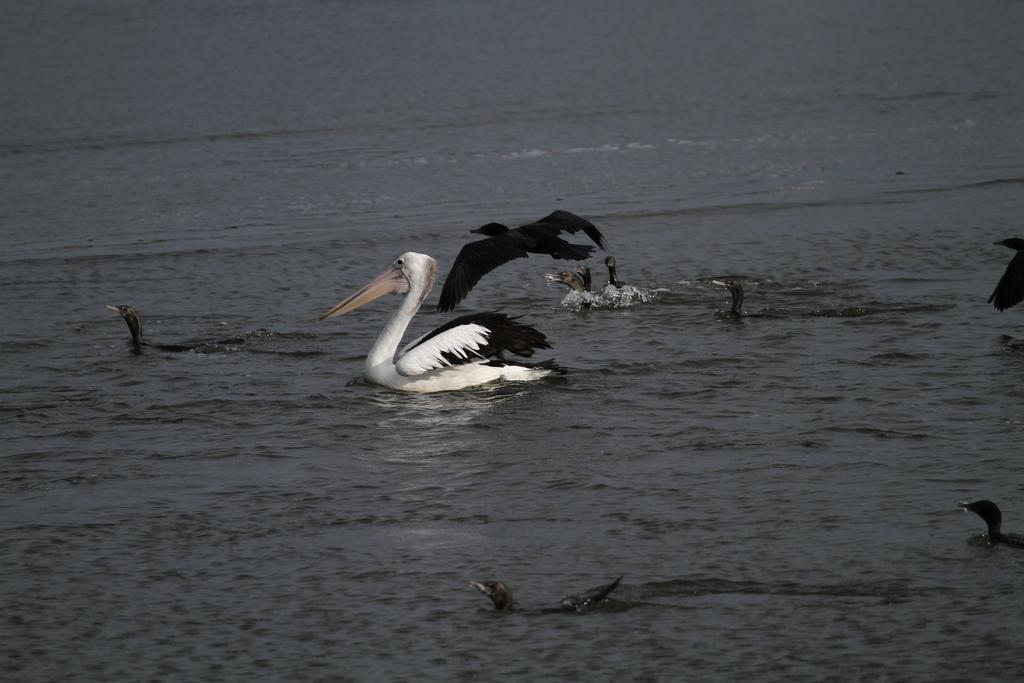Can you describe this image briefly? At the bottom of this image, there are two birds swimming in the water. In the background, there are other birds. Some of them are swimming in the water. 